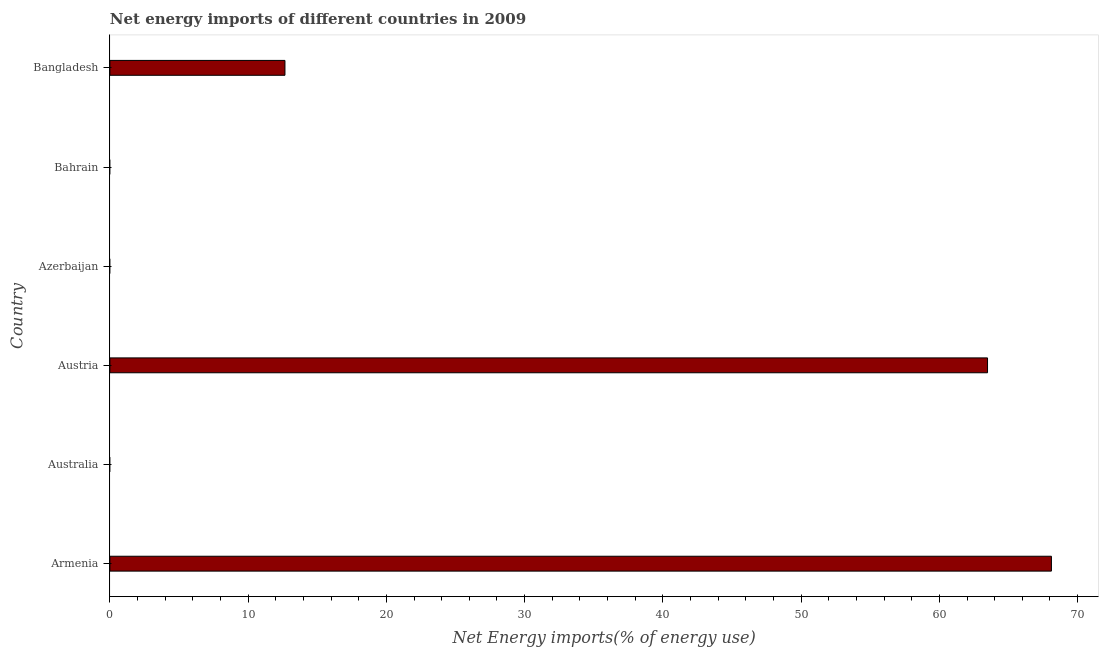Does the graph contain any zero values?
Ensure brevity in your answer.  Yes. What is the title of the graph?
Offer a terse response. Net energy imports of different countries in 2009. What is the label or title of the X-axis?
Ensure brevity in your answer.  Net Energy imports(% of energy use). What is the label or title of the Y-axis?
Your answer should be very brief. Country. What is the energy imports in Azerbaijan?
Your answer should be compact. 0. Across all countries, what is the maximum energy imports?
Keep it short and to the point. 68.11. In which country was the energy imports maximum?
Your response must be concise. Armenia. What is the sum of the energy imports?
Your answer should be compact. 144.25. What is the difference between the energy imports in Armenia and Bangladesh?
Ensure brevity in your answer.  55.44. What is the average energy imports per country?
Your answer should be very brief. 24.04. What is the median energy imports?
Keep it short and to the point. 6.33. In how many countries, is the energy imports greater than 34 %?
Offer a terse response. 2. What is the ratio of the energy imports in Armenia to that in Bangladesh?
Offer a very short reply. 5.38. Is the difference between the energy imports in Armenia and Austria greater than the difference between any two countries?
Offer a terse response. No. What is the difference between the highest and the second highest energy imports?
Make the answer very short. 4.62. Is the sum of the energy imports in Armenia and Bangladesh greater than the maximum energy imports across all countries?
Offer a terse response. Yes. What is the difference between the highest and the lowest energy imports?
Your answer should be compact. 68.11. In how many countries, is the energy imports greater than the average energy imports taken over all countries?
Your response must be concise. 2. How many countries are there in the graph?
Make the answer very short. 6. What is the difference between two consecutive major ticks on the X-axis?
Provide a short and direct response. 10. What is the Net Energy imports(% of energy use) in Armenia?
Offer a terse response. 68.11. What is the Net Energy imports(% of energy use) of Austria?
Provide a succinct answer. 63.48. What is the Net Energy imports(% of energy use) in Azerbaijan?
Offer a very short reply. 0. What is the Net Energy imports(% of energy use) in Bahrain?
Your answer should be very brief. 0. What is the Net Energy imports(% of energy use) of Bangladesh?
Provide a short and direct response. 12.66. What is the difference between the Net Energy imports(% of energy use) in Armenia and Austria?
Your response must be concise. 4.62. What is the difference between the Net Energy imports(% of energy use) in Armenia and Bangladesh?
Ensure brevity in your answer.  55.44. What is the difference between the Net Energy imports(% of energy use) in Austria and Bangladesh?
Provide a succinct answer. 50.82. What is the ratio of the Net Energy imports(% of energy use) in Armenia to that in Austria?
Provide a succinct answer. 1.07. What is the ratio of the Net Energy imports(% of energy use) in Armenia to that in Bangladesh?
Offer a very short reply. 5.38. What is the ratio of the Net Energy imports(% of energy use) in Austria to that in Bangladesh?
Ensure brevity in your answer.  5.01. 